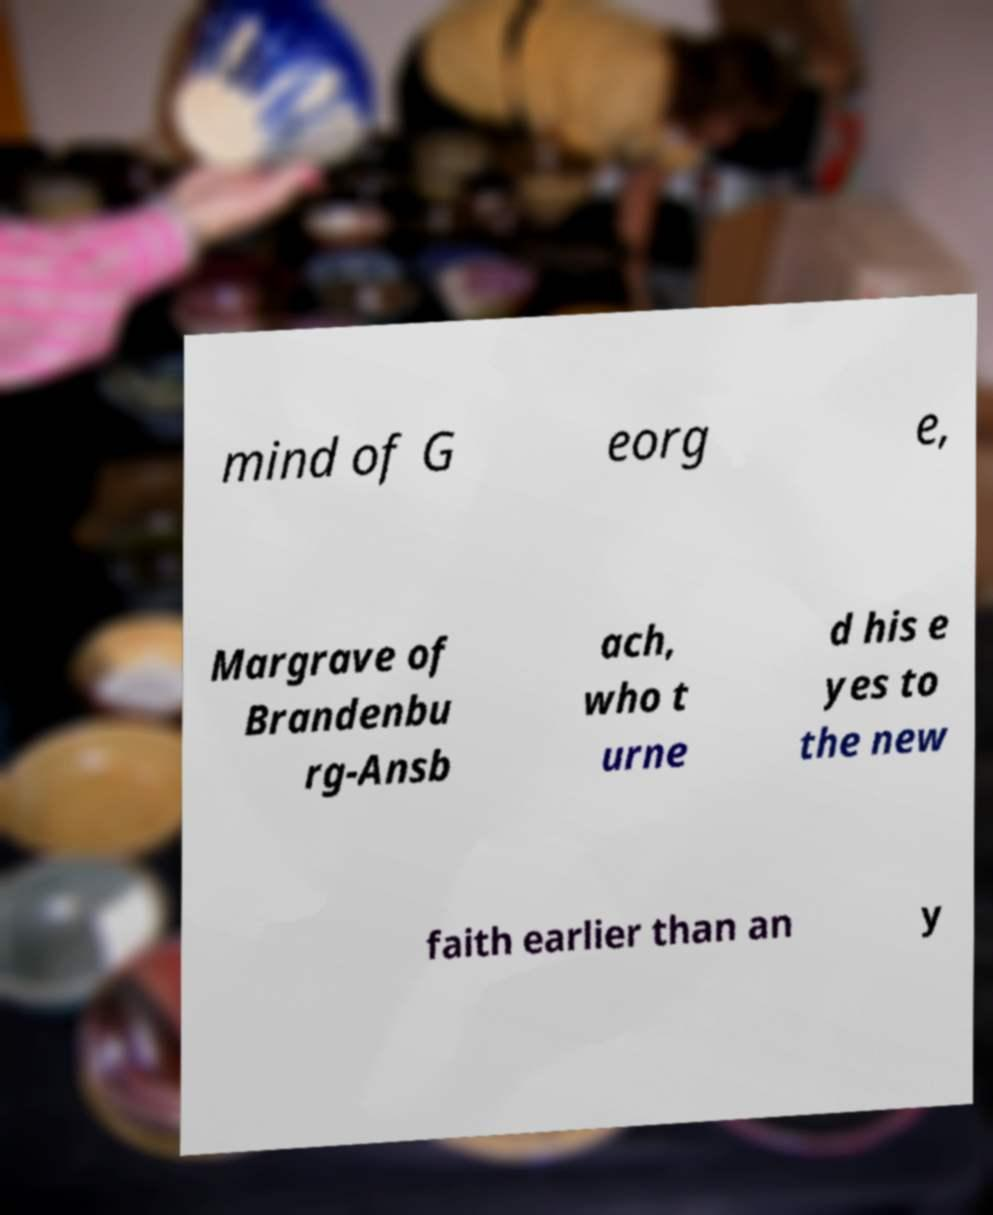Can you read and provide the text displayed in the image?This photo seems to have some interesting text. Can you extract and type it out for me? mind of G eorg e, Margrave of Brandenbu rg-Ansb ach, who t urne d his e yes to the new faith earlier than an y 